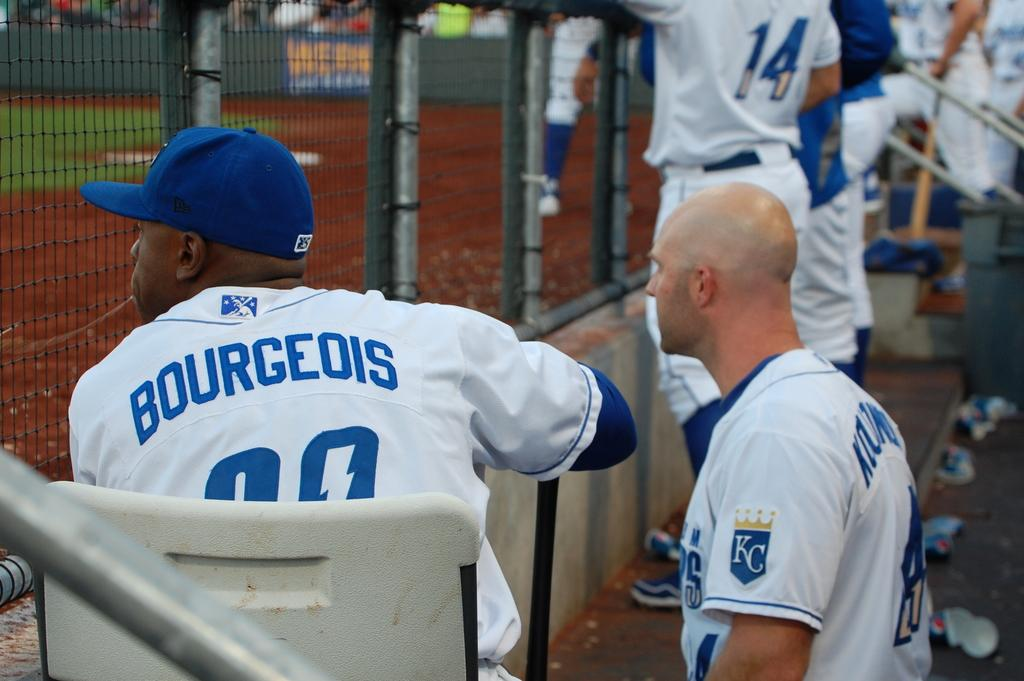<image>
Create a compact narrative representing the image presented. A baseball player sitting in the dugout with Bourgeois on his shirt. 